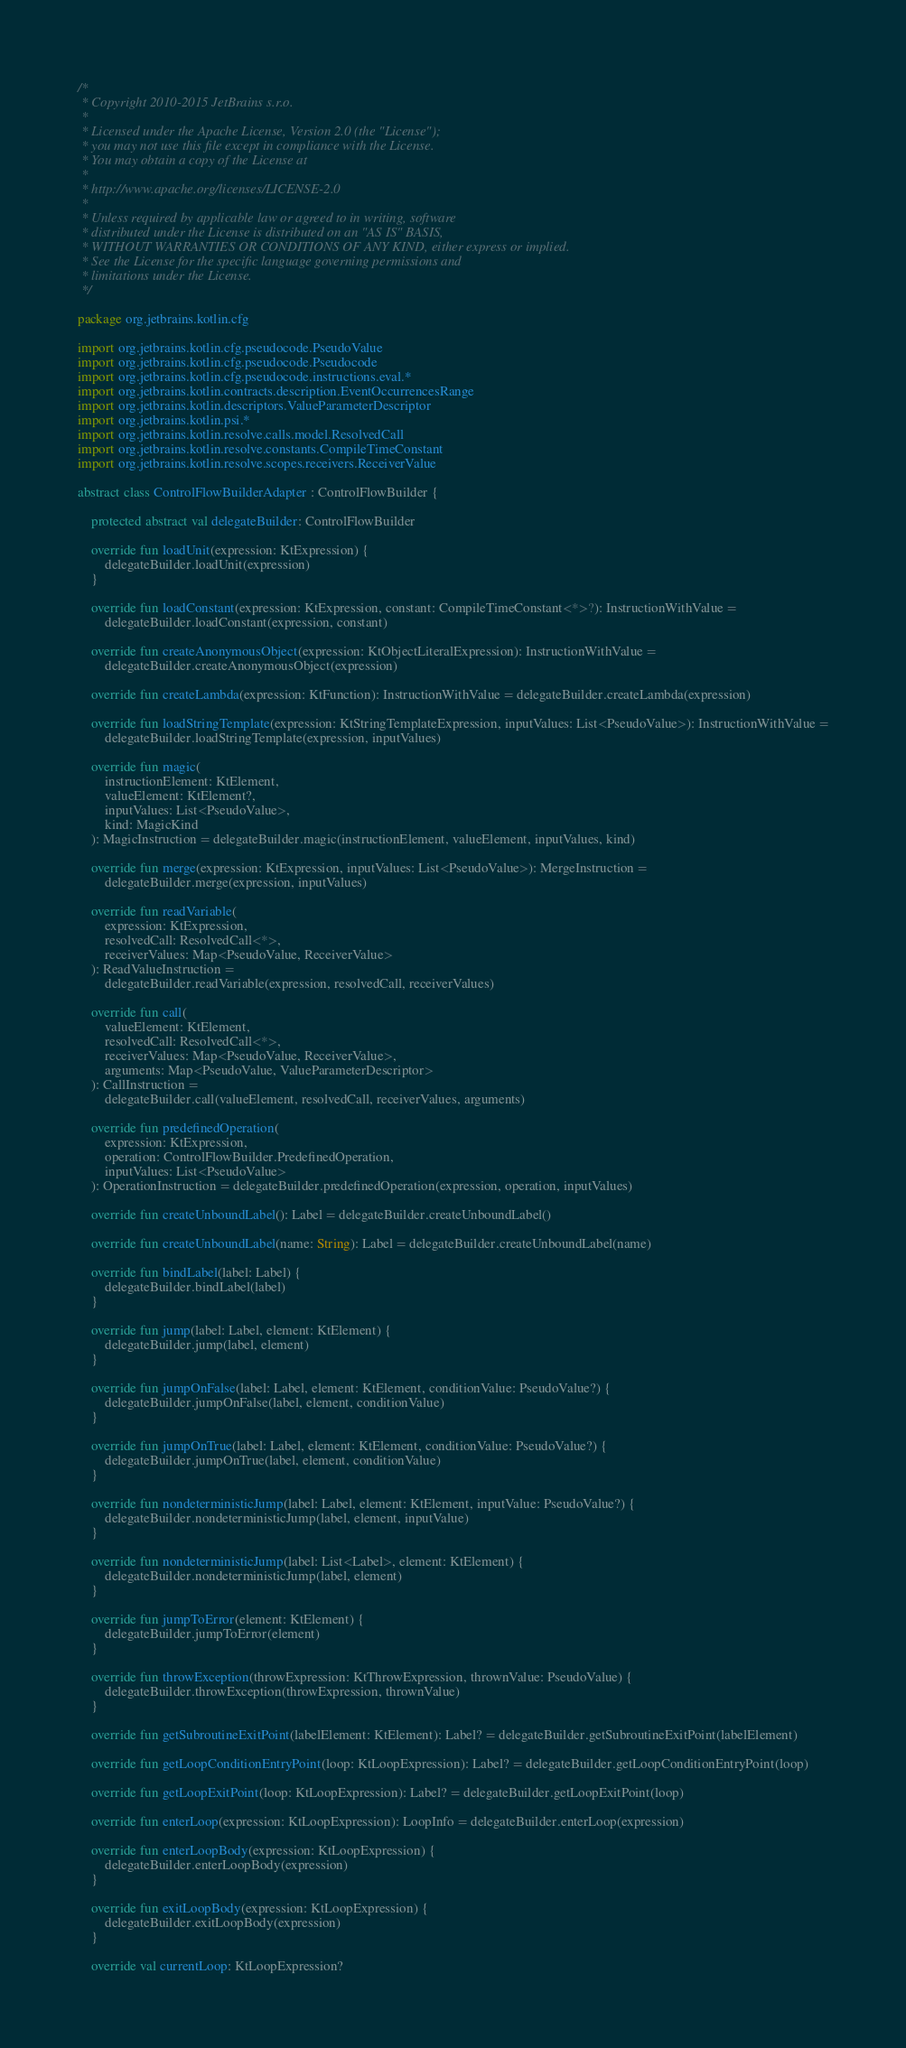<code> <loc_0><loc_0><loc_500><loc_500><_Kotlin_>/*
 * Copyright 2010-2015 JetBrains s.r.o.
 *
 * Licensed under the Apache License, Version 2.0 (the "License");
 * you may not use this file except in compliance with the License.
 * You may obtain a copy of the License at
 *
 * http://www.apache.org/licenses/LICENSE-2.0
 *
 * Unless required by applicable law or agreed to in writing, software
 * distributed under the License is distributed on an "AS IS" BASIS,
 * WITHOUT WARRANTIES OR CONDITIONS OF ANY KIND, either express or implied.
 * See the License for the specific language governing permissions and
 * limitations under the License.
 */

package org.jetbrains.kotlin.cfg

import org.jetbrains.kotlin.cfg.pseudocode.PseudoValue
import org.jetbrains.kotlin.cfg.pseudocode.Pseudocode
import org.jetbrains.kotlin.cfg.pseudocode.instructions.eval.*
import org.jetbrains.kotlin.contracts.description.EventOccurrencesRange
import org.jetbrains.kotlin.descriptors.ValueParameterDescriptor
import org.jetbrains.kotlin.psi.*
import org.jetbrains.kotlin.resolve.calls.model.ResolvedCall
import org.jetbrains.kotlin.resolve.constants.CompileTimeConstant
import org.jetbrains.kotlin.resolve.scopes.receivers.ReceiverValue

abstract class ControlFlowBuilderAdapter : ControlFlowBuilder {

    protected abstract val delegateBuilder: ControlFlowBuilder

    override fun loadUnit(expression: KtExpression) {
        delegateBuilder.loadUnit(expression)
    }

    override fun loadConstant(expression: KtExpression, constant: CompileTimeConstant<*>?): InstructionWithValue =
        delegateBuilder.loadConstant(expression, constant)

    override fun createAnonymousObject(expression: KtObjectLiteralExpression): InstructionWithValue =
        delegateBuilder.createAnonymousObject(expression)

    override fun createLambda(expression: KtFunction): InstructionWithValue = delegateBuilder.createLambda(expression)

    override fun loadStringTemplate(expression: KtStringTemplateExpression, inputValues: List<PseudoValue>): InstructionWithValue =
        delegateBuilder.loadStringTemplate(expression, inputValues)

    override fun magic(
        instructionElement: KtElement,
        valueElement: KtElement?,
        inputValues: List<PseudoValue>,
        kind: MagicKind
    ): MagicInstruction = delegateBuilder.magic(instructionElement, valueElement, inputValues, kind)

    override fun merge(expression: KtExpression, inputValues: List<PseudoValue>): MergeInstruction =
        delegateBuilder.merge(expression, inputValues)

    override fun readVariable(
        expression: KtExpression,
        resolvedCall: ResolvedCall<*>,
        receiverValues: Map<PseudoValue, ReceiverValue>
    ): ReadValueInstruction =
        delegateBuilder.readVariable(expression, resolvedCall, receiverValues)

    override fun call(
        valueElement: KtElement,
        resolvedCall: ResolvedCall<*>,
        receiverValues: Map<PseudoValue, ReceiverValue>,
        arguments: Map<PseudoValue, ValueParameterDescriptor>
    ): CallInstruction =
        delegateBuilder.call(valueElement, resolvedCall, receiverValues, arguments)

    override fun predefinedOperation(
        expression: KtExpression,
        operation: ControlFlowBuilder.PredefinedOperation,
        inputValues: List<PseudoValue>
    ): OperationInstruction = delegateBuilder.predefinedOperation(expression, operation, inputValues)

    override fun createUnboundLabel(): Label = delegateBuilder.createUnboundLabel()

    override fun createUnboundLabel(name: String): Label = delegateBuilder.createUnboundLabel(name)

    override fun bindLabel(label: Label) {
        delegateBuilder.bindLabel(label)
    }

    override fun jump(label: Label, element: KtElement) {
        delegateBuilder.jump(label, element)
    }

    override fun jumpOnFalse(label: Label, element: KtElement, conditionValue: PseudoValue?) {
        delegateBuilder.jumpOnFalse(label, element, conditionValue)
    }

    override fun jumpOnTrue(label: Label, element: KtElement, conditionValue: PseudoValue?) {
        delegateBuilder.jumpOnTrue(label, element, conditionValue)
    }

    override fun nondeterministicJump(label: Label, element: KtElement, inputValue: PseudoValue?) {
        delegateBuilder.nondeterministicJump(label, element, inputValue)
    }

    override fun nondeterministicJump(label: List<Label>, element: KtElement) {
        delegateBuilder.nondeterministicJump(label, element)
    }

    override fun jumpToError(element: KtElement) {
        delegateBuilder.jumpToError(element)
    }

    override fun throwException(throwExpression: KtThrowExpression, thrownValue: PseudoValue) {
        delegateBuilder.throwException(throwExpression, thrownValue)
    }

    override fun getSubroutineExitPoint(labelElement: KtElement): Label? = delegateBuilder.getSubroutineExitPoint(labelElement)

    override fun getLoopConditionEntryPoint(loop: KtLoopExpression): Label? = delegateBuilder.getLoopConditionEntryPoint(loop)

    override fun getLoopExitPoint(loop: KtLoopExpression): Label? = delegateBuilder.getLoopExitPoint(loop)

    override fun enterLoop(expression: KtLoopExpression): LoopInfo = delegateBuilder.enterLoop(expression)

    override fun enterLoopBody(expression: KtLoopExpression) {
        delegateBuilder.enterLoopBody(expression)
    }

    override fun exitLoopBody(expression: KtLoopExpression) {
        delegateBuilder.exitLoopBody(expression)
    }

    override val currentLoop: KtLoopExpression?</code> 